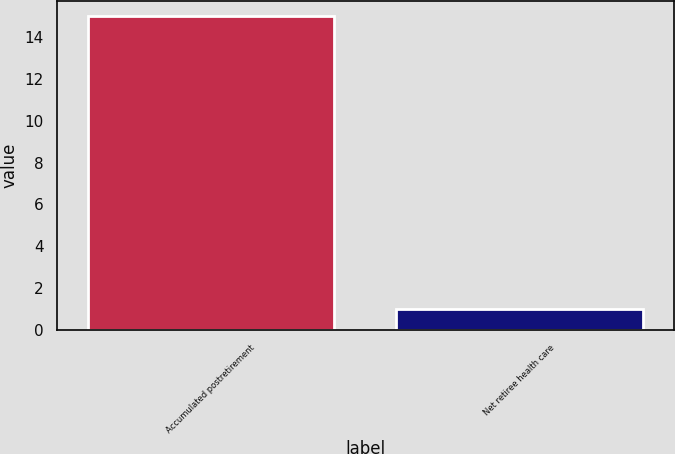Convert chart to OTSL. <chart><loc_0><loc_0><loc_500><loc_500><bar_chart><fcel>Accumulated postretirement<fcel>Net retiree health care<nl><fcel>15<fcel>1<nl></chart> 